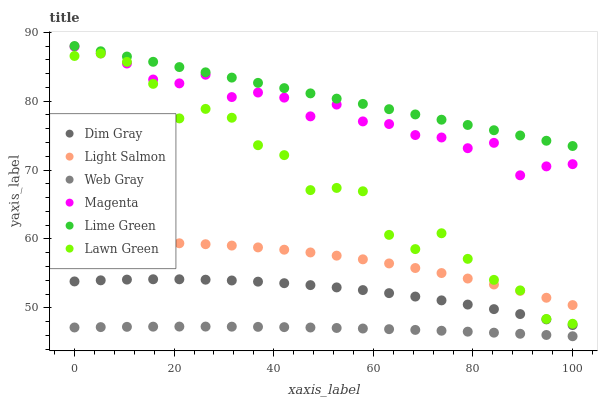Does Web Gray have the minimum area under the curve?
Answer yes or no. Yes. Does Lime Green have the maximum area under the curve?
Answer yes or no. Yes. Does Light Salmon have the minimum area under the curve?
Answer yes or no. No. Does Light Salmon have the maximum area under the curve?
Answer yes or no. No. Is Lime Green the smoothest?
Answer yes or no. Yes. Is Lawn Green the roughest?
Answer yes or no. Yes. Is Light Salmon the smoothest?
Answer yes or no. No. Is Light Salmon the roughest?
Answer yes or no. No. Does Web Gray have the lowest value?
Answer yes or no. Yes. Does Light Salmon have the lowest value?
Answer yes or no. No. Does Lime Green have the highest value?
Answer yes or no. Yes. Does Light Salmon have the highest value?
Answer yes or no. No. Is Dim Gray less than Lime Green?
Answer yes or no. Yes. Is Magenta greater than Dim Gray?
Answer yes or no. Yes. Does Magenta intersect Lawn Green?
Answer yes or no. Yes. Is Magenta less than Lawn Green?
Answer yes or no. No. Is Magenta greater than Lawn Green?
Answer yes or no. No. Does Dim Gray intersect Lime Green?
Answer yes or no. No. 